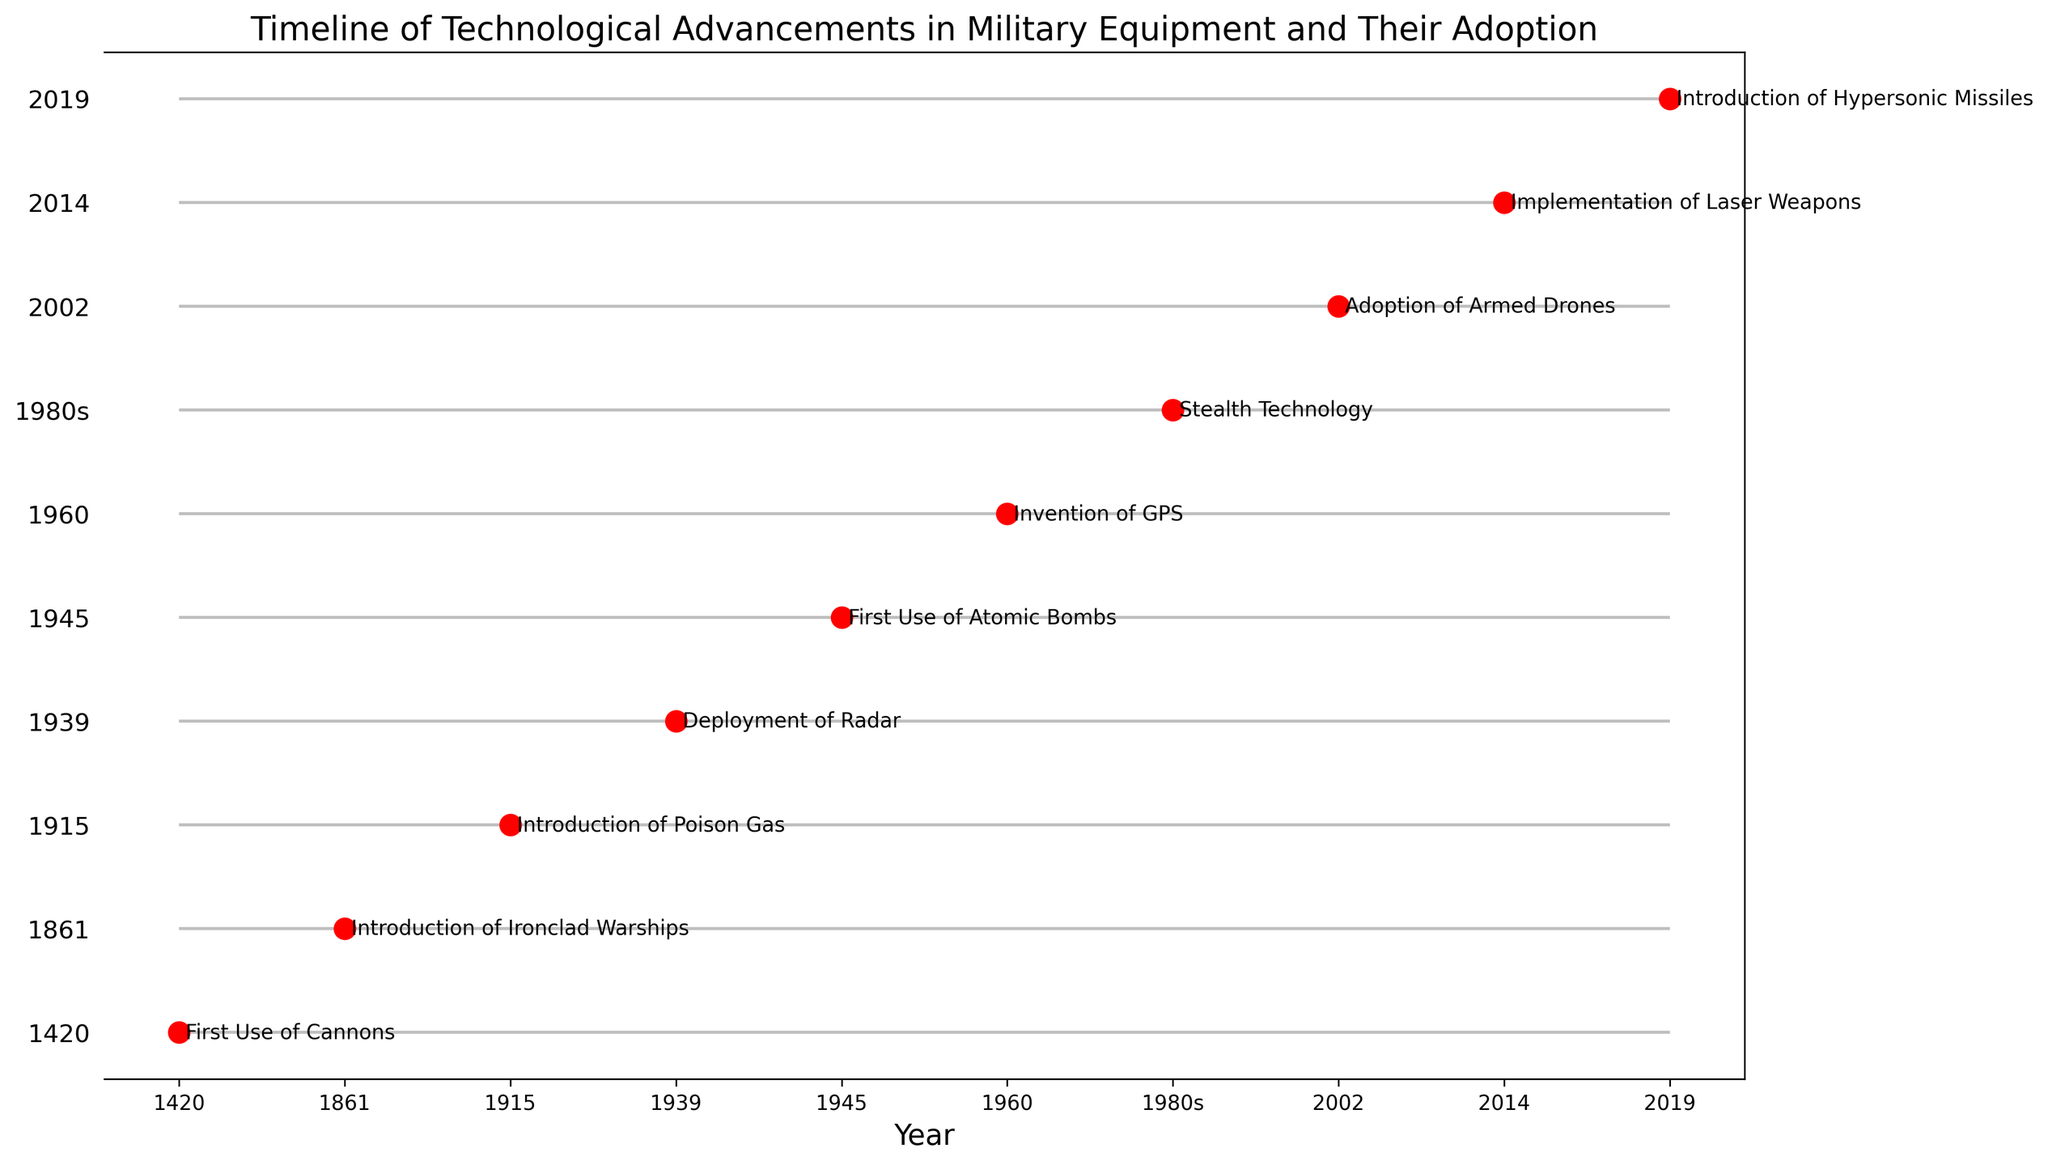What's the first technological advancement listed on the timeline? The first technological advancement listed, as indicated by the earliest year on the timeline, is the "First Use of Cannons" in 1420.
Answer: First Use of Cannons Which two events in the timeline occurred during the 20th century? The events that took place during the 20th century according to the timeline are the "Deployment of Radar" in 1939 and the "First Use of Atomic Bombs" in 1945.
Answer: Deployment of Radar and First Use of Atomic Bombs How many years apart were the invention of GPS and the adoption of armed drones? The invention of GPS occurred in 1960, and the adoption of armed drones happened in 2002. The difference between these years is 2002 - 1960 = 42 years.
Answer: 42 years What event follows the introduction of poison gas chronologically on the timeline? According to the timeline, the event that follows the "Introduction of Poison Gas" in 1915 is the "Deployment of Radar" in 1939.
Answer: Deployment of Radar In which year was laser weapons first implemented according to the timeline? The timeline indicates that laser weapons were first implemented in 2014.
Answer: 2014 Which event had the longest gap between it and the preceding event on the timeline? By examining the intervals between each pair of consecutive events, we find the longest gap is between the "First Use of Cannons" in 1420 and the "Introduction of Ironclad Warships" in 1861, which is 1861 - 1420 = 441 years.
Answer: Introduction of Ironclad Warships Between the deployment of radar and the invention of GPS, what other event took place? The other event that occurred between "Deployment of Radar" in 1939 and "Invention of GPS" in 1960 is the "First Use of Atomic Bombs" in 1945.
Answer: First Use of Atomic Bombs What is the most recent event on the timeline? The most recent event listed on the timeline is the "Introduction of Hypersonic Missiles" in 2019.
Answer: Introduction of Hypersonic Missiles 